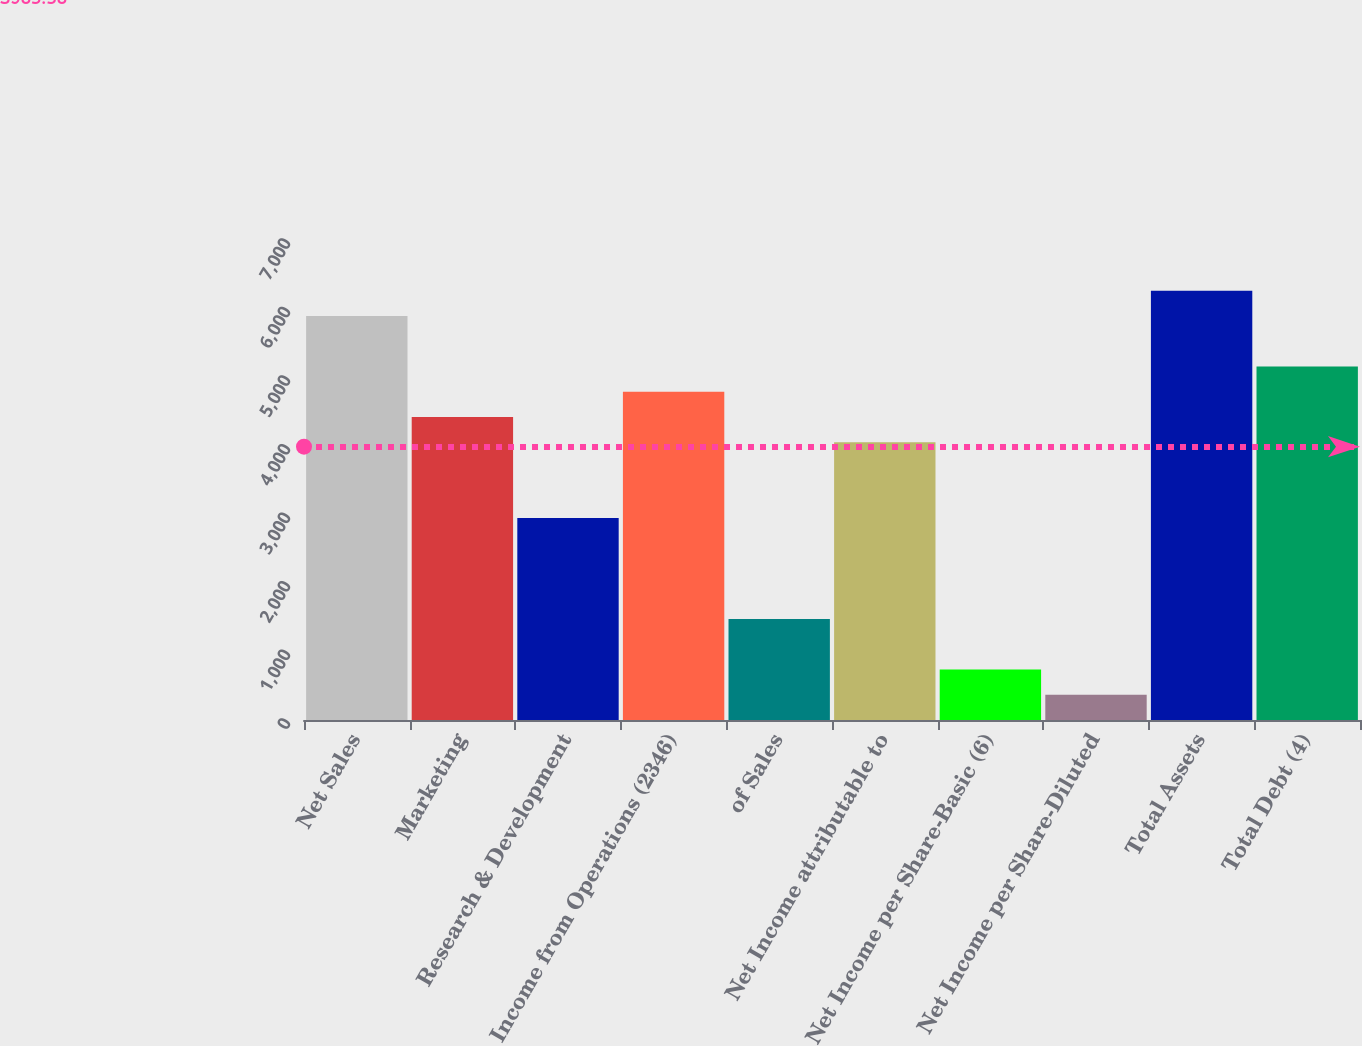Convert chart. <chart><loc_0><loc_0><loc_500><loc_500><bar_chart><fcel>Net Sales<fcel>Marketing<fcel>Research & Development<fcel>Income from Operations (2346)<fcel>of Sales<fcel>Net Income attributable to<fcel>Net Income per Share-Basic (6)<fcel>Net Income per Share-Diluted<fcel>Total Assets<fcel>Total Debt (4)<nl><fcel>5891.15<fcel>4418.39<fcel>2945.63<fcel>4786.58<fcel>1472.88<fcel>4050.2<fcel>736.51<fcel>368.33<fcel>6259.34<fcel>5154.77<nl></chart> 